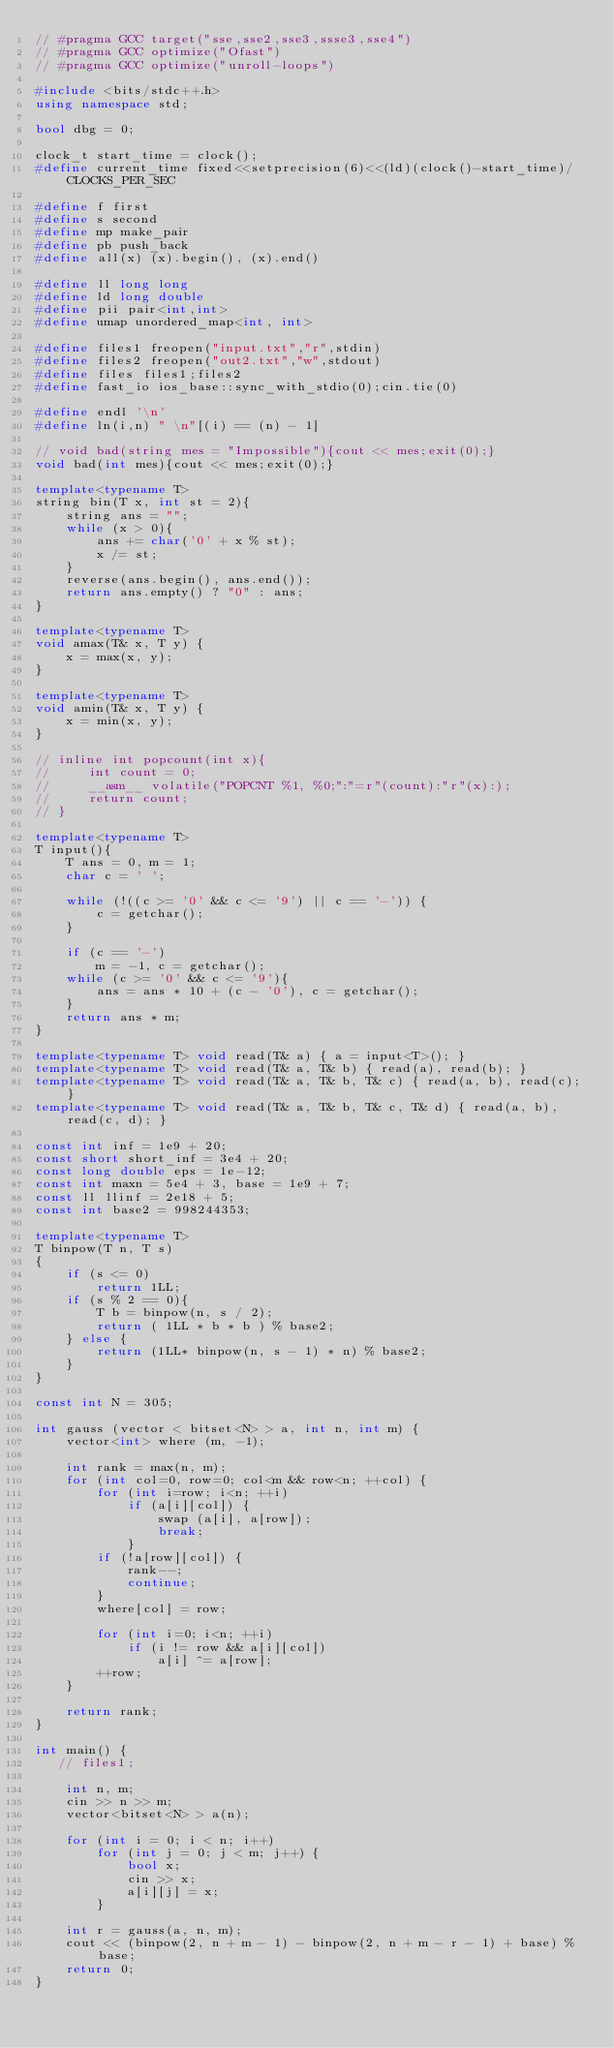Convert code to text. <code><loc_0><loc_0><loc_500><loc_500><_C++_>// #pragma GCC target("sse,sse2,sse3,ssse3,sse4")
// #pragma GCC optimize("Ofast")
// #pragma GCC optimize("unroll-loops")

#include <bits/stdc++.h>
using namespace std;
  
bool dbg = 0;
  
clock_t start_time = clock();
#define current_time fixed<<setprecision(6)<<(ld)(clock()-start_time)/CLOCKS_PER_SEC
  
#define f first
#define s second
#define mp make_pair
#define pb push_back
#define all(x) (x).begin(), (x).end()
  
#define ll long long
#define ld long double
#define pii pair<int,int>
#define umap unordered_map<int, int>
  
#define files1 freopen("input.txt","r",stdin)
#define files2 freopen("out2.txt","w",stdout)
#define files files1;files2
#define fast_io ios_base::sync_with_stdio(0);cin.tie(0)
  
#define endl '\n'
#define ln(i,n) " \n"[(i) == (n) - 1]
  
// void bad(string mes = "Impossible"){cout << mes;exit(0);}
void bad(int mes){cout << mes;exit(0);}
  
template<typename T>
string bin(T x, int st = 2){
    string ans = "";
    while (x > 0){
        ans += char('0' + x % st);
        x /= st;
    }
    reverse(ans.begin(), ans.end());
    return ans.empty() ? "0" : ans;
}
  
template<typename T>
void amax(T& x, T y) {
    x = max(x, y);
}
  
template<typename T>
void amin(T& x, T y) {
    x = min(x, y);
}

// inline int popcount(int x){
//     int count = 0;
//     __asm__ volatile("POPCNT %1, %0;":"=r"(count):"r"(x):);
//     return count;
// }
  
template<typename T>
T input(){
    T ans = 0, m = 1;
    char c = ' ';
  
    while (!((c >= '0' && c <= '9') || c == '-')) {
        c = getchar();
    }
  
    if (c == '-')
        m = -1, c = getchar();
    while (c >= '0' && c <= '9'){
        ans = ans * 10 + (c - '0'), c = getchar();
    }
    return ans * m;
}
  
template<typename T> void read(T& a) { a = input<T>(); }
template<typename T> void read(T& a, T& b) { read(a), read(b); }
template<typename T> void read(T& a, T& b, T& c) { read(a, b), read(c); }
template<typename T> void read(T& a, T& b, T& c, T& d) { read(a, b), read(c, d); }
  
const int inf = 1e9 + 20;
const short short_inf = 3e4 + 20;
const long double eps = 1e-12;
const int maxn = 5e4 + 3, base = 1e9 + 7;
const ll llinf = 2e18 + 5;
const int base2 = 998244353;
  
template<typename T>
T binpow(T n, T s)
{
    if (s <= 0)
        return 1LL;
    if (s % 2 == 0){
        T b = binpow(n, s / 2);
        return ( 1LL * b * b ) % base2;
    } else {
        return (1LL* binpow(n, s - 1) * n) % base2;
    }
}

const int N = 305;

int gauss (vector < bitset<N> > a, int n, int m) {    
    vector<int> where (m, -1);
    
    int rank = max(n, m);
    for (int col=0, row=0; col<m && row<n; ++col) {
        for (int i=row; i<n; ++i)
            if (a[i][col]) {
                swap (a[i], a[row]);
                break;
            }
        if (!a[row][col]) {
            rank--;
            continue;
        }
        where[col] = row;

        for (int i=0; i<n; ++i)
            if (i != row && a[i][col])
                a[i] ^= a[row];
        ++row;
    }

    return rank;
}

int main() {
   // files1;

    int n, m;
    cin >> n >> m;
    vector<bitset<N> > a(n);

    for (int i = 0; i < n; i++)
        for (int j = 0; j < m; j++) {
            bool x;
            cin >> x;
            a[i][j] = x;
        }

    int r = gauss(a, n, m);
    cout << (binpow(2, n + m - 1) - binpow(2, n + m - r - 1) + base) % base;
    return 0;
}</code> 